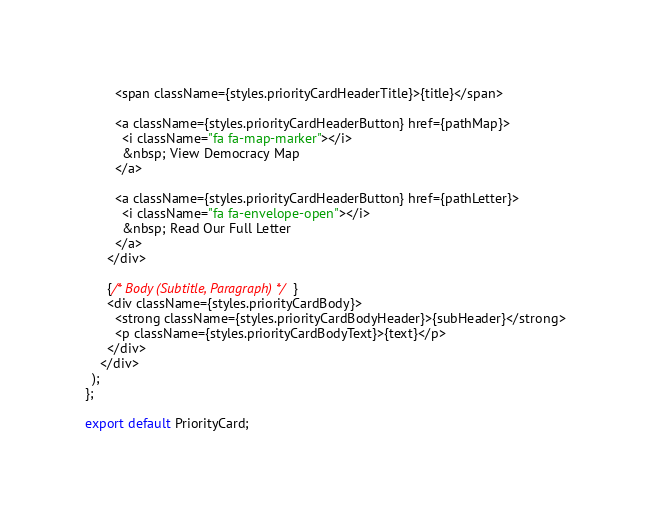<code> <loc_0><loc_0><loc_500><loc_500><_JavaScript_>        <span className={styles.priorityCardHeaderTitle}>{title}</span>

        <a className={styles.priorityCardHeaderButton} href={pathMap}>
          <i className="fa fa-map-marker"></i>
          &nbsp; View Democracy Map
        </a>

        <a className={styles.priorityCardHeaderButton} href={pathLetter}>
          <i className="fa fa-envelope-open"></i>
          &nbsp; Read Our Full Letter
        </a>
      </div>

      {/* Body (Subtitle, Paragraph) */}
      <div className={styles.priorityCardBody}>
        <strong className={styles.priorityCardBodyHeader}>{subHeader}</strong>
        <p className={styles.priorityCardBodyText}>{text}</p>
      </div>
    </div>
  );
};

export default PriorityCard;

</code> 